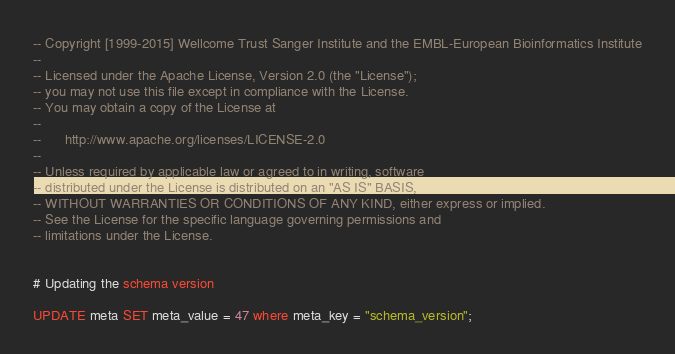Convert code to text. <code><loc_0><loc_0><loc_500><loc_500><_SQL_>-- Copyright [1999-2015] Wellcome Trust Sanger Institute and the EMBL-European Bioinformatics Institute
-- 
-- Licensed under the Apache License, Version 2.0 (the "License");
-- you may not use this file except in compliance with the License.
-- You may obtain a copy of the License at
-- 
--      http://www.apache.org/licenses/LICENSE-2.0
-- 
-- Unless required by applicable law or agreed to in writing, software
-- distributed under the License is distributed on an "AS IS" BASIS,
-- WITHOUT WARRANTIES OR CONDITIONS OF ANY KIND, either express or implied.
-- See the License for the specific language governing permissions and
-- limitations under the License.


# Updating the schema version

UPDATE meta SET meta_value = 47 where meta_key = "schema_version";
</code> 